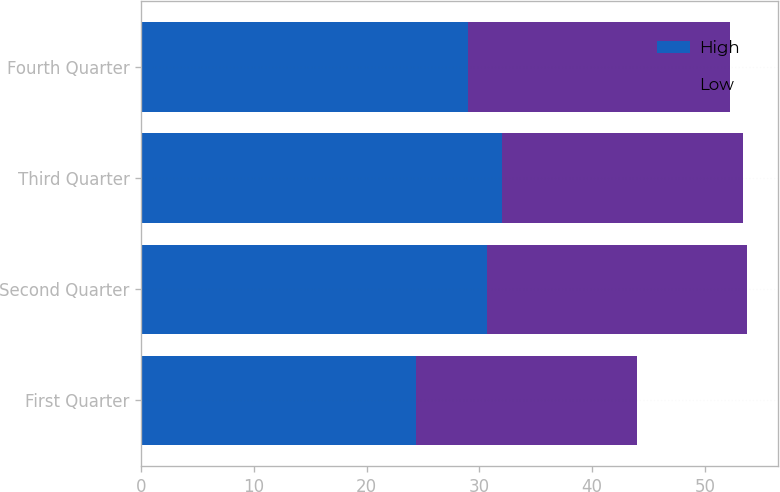<chart> <loc_0><loc_0><loc_500><loc_500><stacked_bar_chart><ecel><fcel>First Quarter<fcel>Second Quarter<fcel>Third Quarter<fcel>Fourth Quarter<nl><fcel>High<fcel>24.4<fcel>30.67<fcel>32.01<fcel>29<nl><fcel>Low<fcel>19.56<fcel>23.1<fcel>21.37<fcel>23.27<nl></chart> 